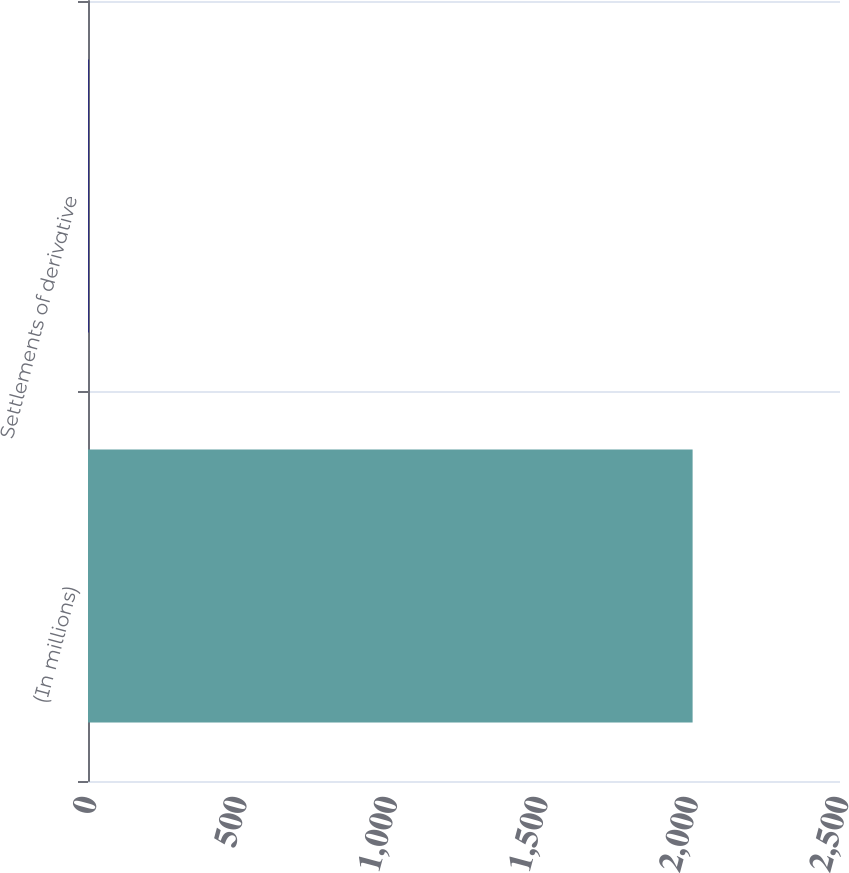Convert chart to OTSL. <chart><loc_0><loc_0><loc_500><loc_500><bar_chart><fcel>(In millions)<fcel>Settlements of derivative<nl><fcel>2010<fcel>2<nl></chart> 